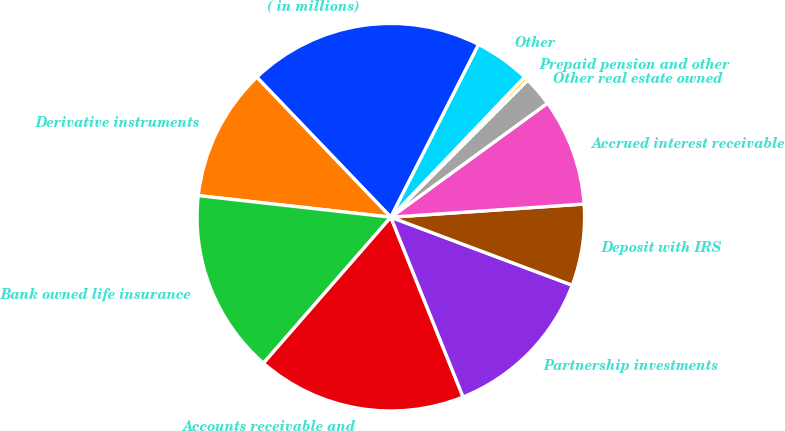<chart> <loc_0><loc_0><loc_500><loc_500><pie_chart><fcel>( in millions)<fcel>Derivative instruments<fcel>Bank owned life insurance<fcel>Accounts receivable and<fcel>Partnership investments<fcel>Deposit with IRS<fcel>Accrued interest receivable<fcel>Other real estate owned<fcel>Prepaid pension and other<fcel>Other<nl><fcel>19.64%<fcel>11.07%<fcel>15.36%<fcel>17.5%<fcel>13.21%<fcel>6.79%<fcel>8.93%<fcel>2.5%<fcel>0.36%<fcel>4.64%<nl></chart> 